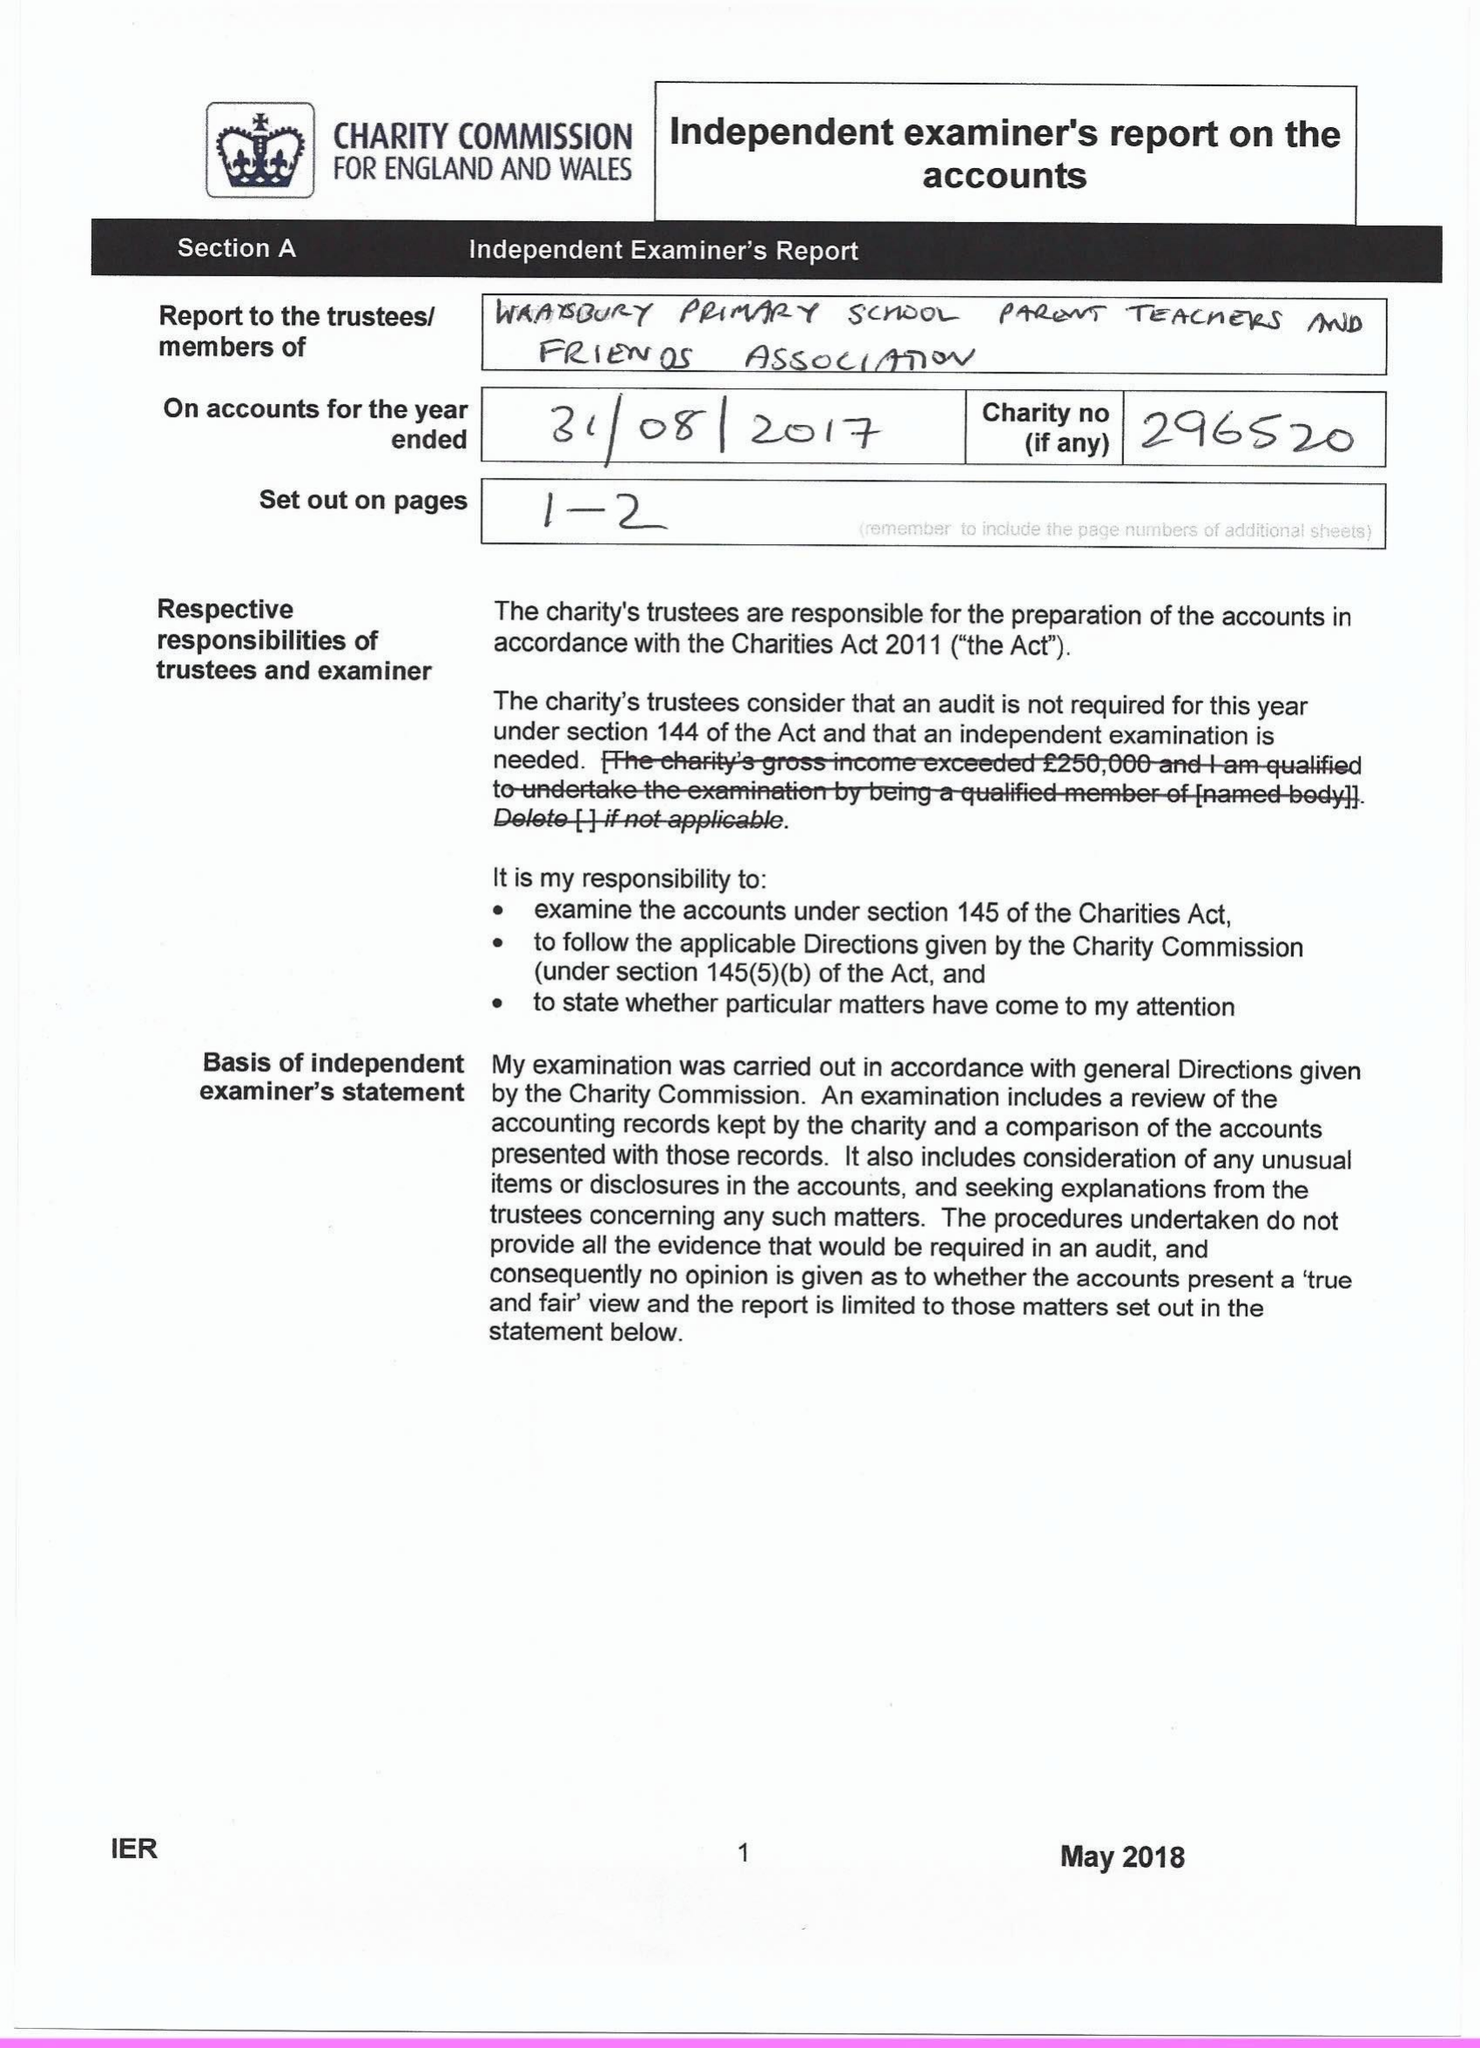What is the value for the report_date?
Answer the question using a single word or phrase. 2017-08-31 